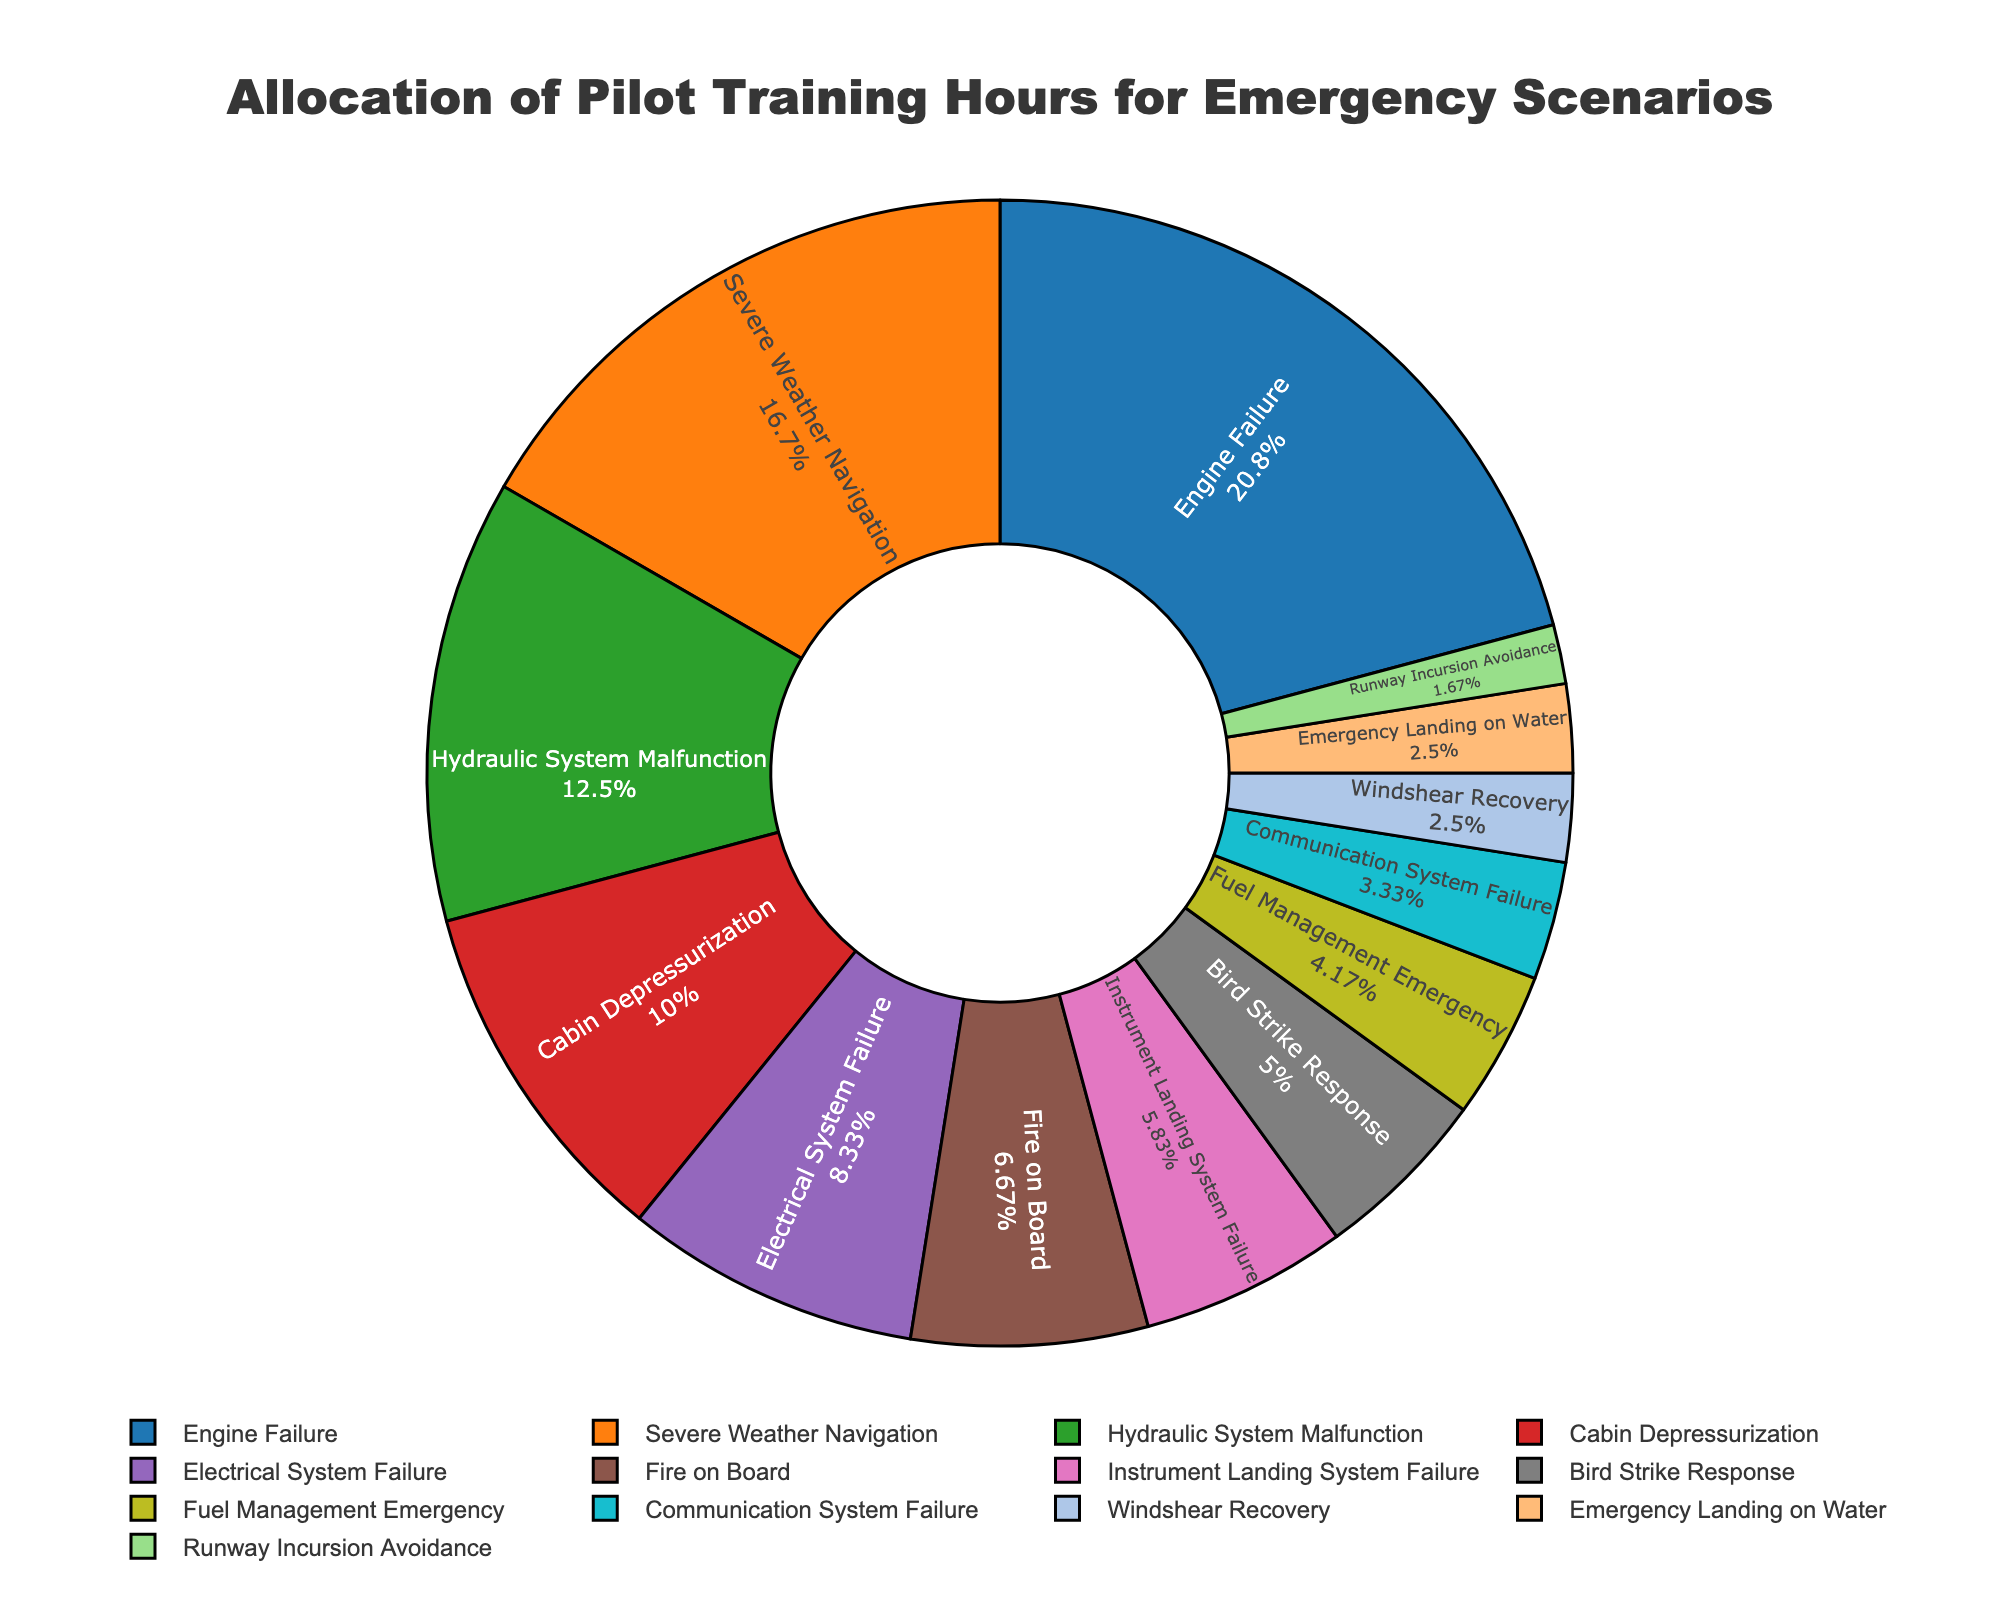Which scenario received the most training hours? The scenario with the largest section of the pie chart represents the most training hours.
Answer: Engine Failure How many hours were allocated to severe weather navigation and fire on board combined? Add the hours for Severe Weather Navigation (20) and Fire on Board (8): 20 + 8 = 28
Answer: 28 Which scenario has fewer training hours, bird strike response or windshear recovery? Compare the sections for Bird Strike Response (6 hours) and Windshear Recovery (3 hours) based on their sizes.
Answer: Windshear recovery What percentage of the total training hours is dedicated to hydraulic system malfunction? Find the slice labeled Hydraulic System Malfunction and note its percentage from the chart.
Answer: 15% Is electrical system failure allocated more training hours than fuel management emergency? Compare the sizes of the slices for Electrical System Failure (10 hours) and Fuel Management Emergency (5 hours).
Answer: Yes Which scenario's training hours allocation is equal to the sum of runways incursion avoidance and emergency landing on water? Find the slice whose hours match the sum of Runway Incursion Avoidance (2) and Emergency Landing on Water (3): 2 + 3 = 5.
Answer: Fuel Management Emergency How does the training allocation for instrument landing system failure compare to cabin depressurization? Compare the portions of the pie chart for Instrument Landing System Failure (7 hours) and Cabin Depressurization (12 hours).
Answer: Less What total proportion of training hours is allocated to scenarios involving instrumentation failure (engine, hydraulic, electrical)? Analyze the proportions of Engine Failure (25), Hydraulic System Malfunction (15), and Electrical System Failure (10) and sum their percentages/values.
Answer: 50 What are the combined training hours for the three least prioritized scenarios? Sum the hours for Runway Incursion Avoidance (2), Emergency Landing on Water (3), and Windshear Recovery (3): 2 + 3 + 3 = 8
Answer: 8 